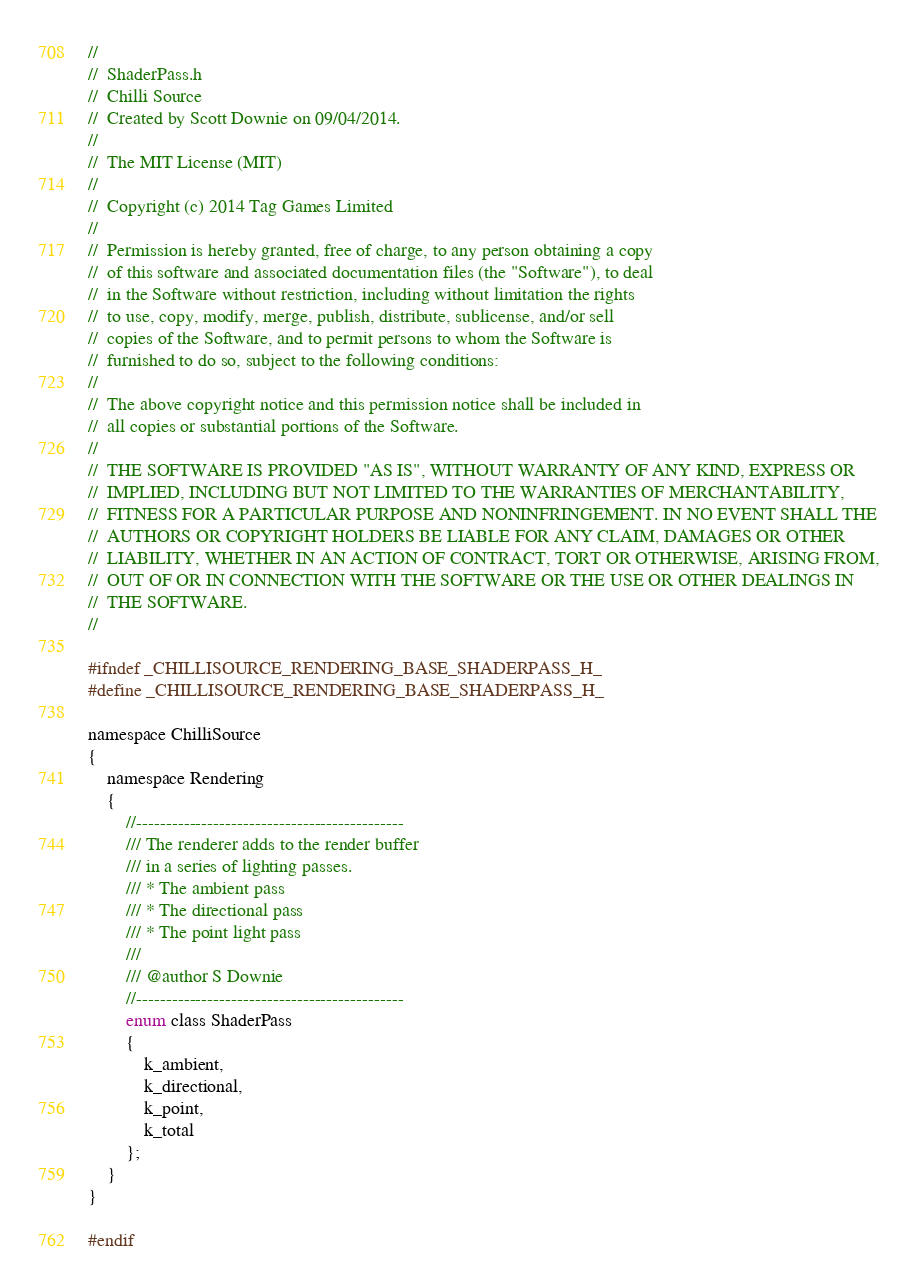<code> <loc_0><loc_0><loc_500><loc_500><_C_>//
//  ShaderPass.h
//  Chilli Source
//  Created by Scott Downie on 09/04/2014.
//
//  The MIT License (MIT)
//
//  Copyright (c) 2014 Tag Games Limited
//
//  Permission is hereby granted, free of charge, to any person obtaining a copy
//  of this software and associated documentation files (the "Software"), to deal
//  in the Software without restriction, including without limitation the rights
//  to use, copy, modify, merge, publish, distribute, sublicense, and/or sell
//  copies of the Software, and to permit persons to whom the Software is
//  furnished to do so, subject to the following conditions:
//
//  The above copyright notice and this permission notice shall be included in
//  all copies or substantial portions of the Software.
//
//  THE SOFTWARE IS PROVIDED "AS IS", WITHOUT WARRANTY OF ANY KIND, EXPRESS OR
//  IMPLIED, INCLUDING BUT NOT LIMITED TO THE WARRANTIES OF MERCHANTABILITY,
//  FITNESS FOR A PARTICULAR PURPOSE AND NONINFRINGEMENT. IN NO EVENT SHALL THE
//  AUTHORS OR COPYRIGHT HOLDERS BE LIABLE FOR ANY CLAIM, DAMAGES OR OTHER
//  LIABILITY, WHETHER IN AN ACTION OF CONTRACT, TORT OR OTHERWISE, ARISING FROM,
//  OUT OF OR IN CONNECTION WITH THE SOFTWARE OR THE USE OR OTHER DEALINGS IN
//  THE SOFTWARE.
//

#ifndef _CHILLISOURCE_RENDERING_BASE_SHADERPASS_H_
#define _CHILLISOURCE_RENDERING_BASE_SHADERPASS_H_

namespace ChilliSource
{
	namespace Rendering
	{
        //---------------------------------------------
        /// The renderer adds to the render buffer
        /// in a series of lighting passes.
        /// * The ambient pass
        /// * The directional pass
        /// * The point light pass
        ///
        /// @author S Downie
        //---------------------------------------------
        enum class ShaderPass
        {
            k_ambient,
            k_directional,
            k_point,
            k_total
        };
	}
}

#endif</code> 